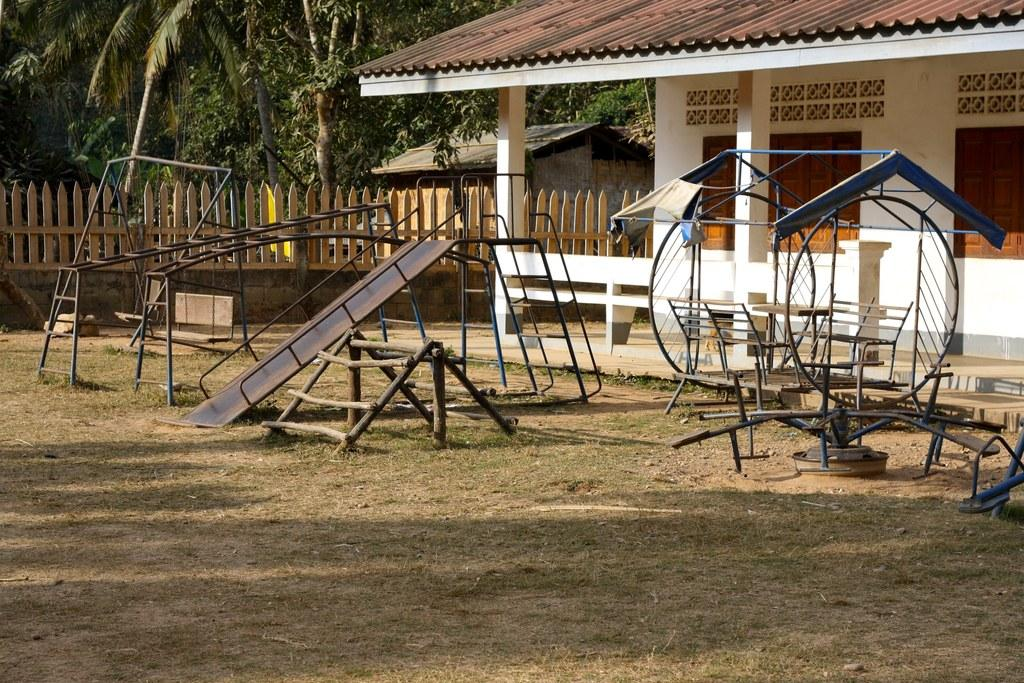What type of structures can be seen in the image? There are houses with rooftops in the image. What recreational area is visible in the image? There is a playground in the image. What feature does the playground have? The playground has a slide. What can be used for playing in the playground? There are playing objects in the playground. What type of barrier is present in the image? There is a fence in the image. What type of vegetation is present in the image? Trees are present in the image. What color of paint is being used to cover the lead in the image? There is no mention of paint or lead in the image; it features houses, a playground, and trees. 